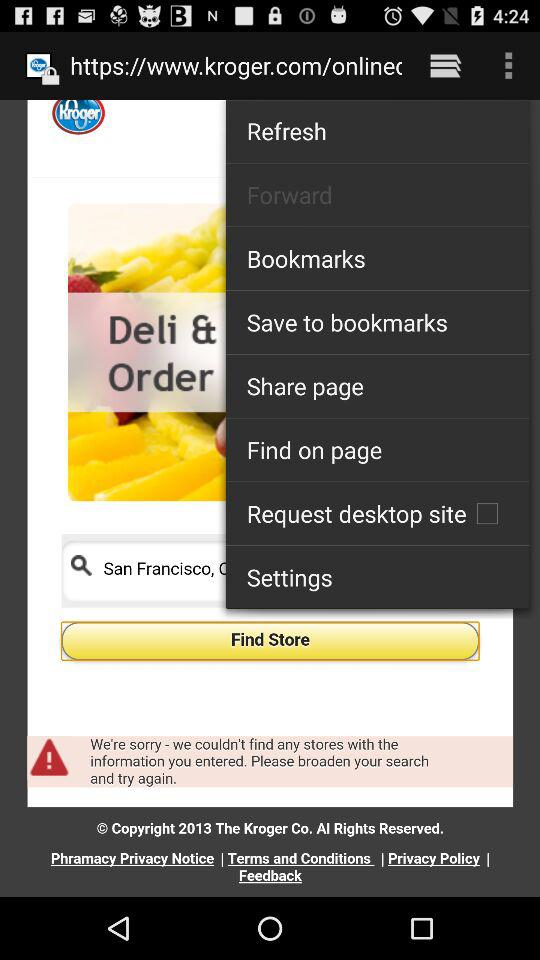What is the application name? The application name is "Kroger". 